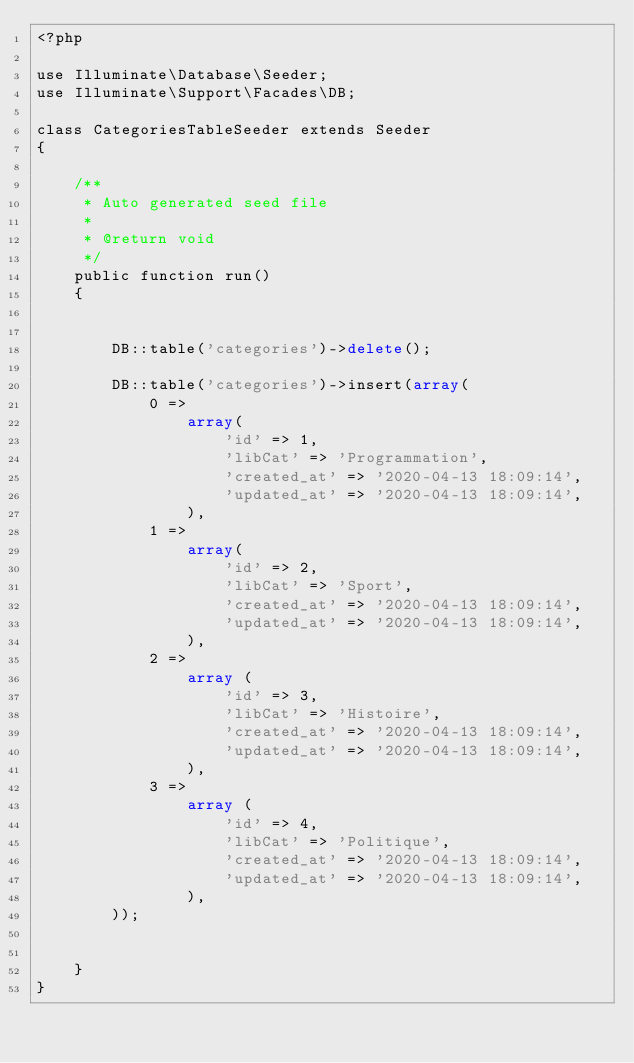Convert code to text. <code><loc_0><loc_0><loc_500><loc_500><_PHP_><?php

use Illuminate\Database\Seeder;
use Illuminate\Support\Facades\DB;

class CategoriesTableSeeder extends Seeder
{

    /**
     * Auto generated seed file
     *
     * @return void
     */
    public function run()
    {


        DB::table('categories')->delete();

        DB::table('categories')->insert(array(
            0 =>
                array(
                    'id' => 1,
                    'libCat' => 'Programmation',
                    'created_at' => '2020-04-13 18:09:14',
                    'updated_at' => '2020-04-13 18:09:14',
                ),
            1 =>
                array(
                    'id' => 2,
                    'libCat' => 'Sport',
                    'created_at' => '2020-04-13 18:09:14',
                    'updated_at' => '2020-04-13 18:09:14',
                ),
            2 =>
                array (
                    'id' => 3,
                    'libCat' => 'Histoire',
                    'created_at' => '2020-04-13 18:09:14',
                    'updated_at' => '2020-04-13 18:09:14',
                ),
            3 =>
                array (
                    'id' => 4,
                    'libCat' => 'Politique',
                    'created_at' => '2020-04-13 18:09:14',
                    'updated_at' => '2020-04-13 18:09:14',
                ),
        ));


    }
}
</code> 